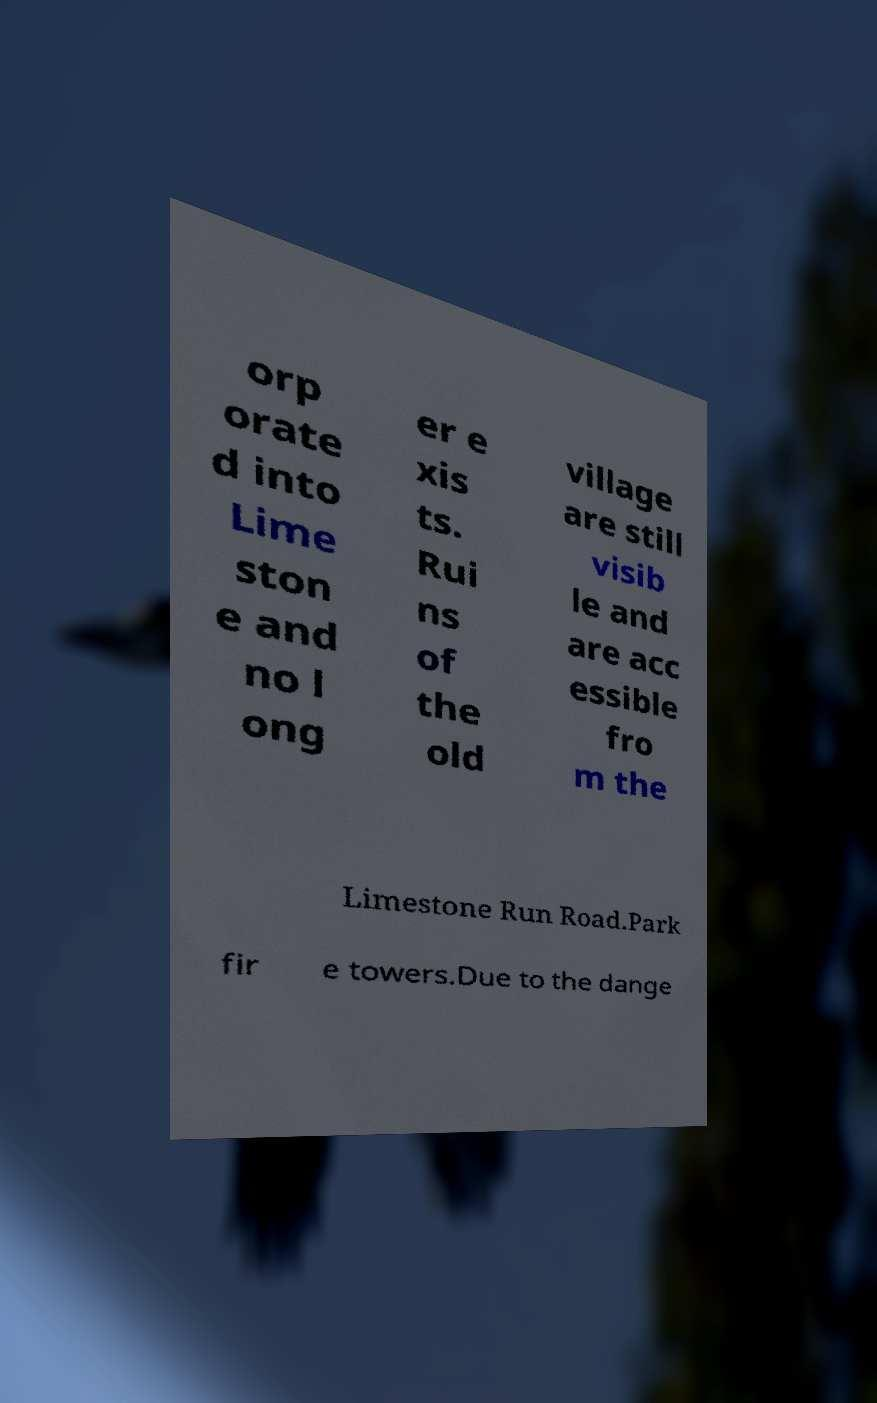For documentation purposes, I need the text within this image transcribed. Could you provide that? orp orate d into Lime ston e and no l ong er e xis ts. Rui ns of the old village are still visib le and are acc essible fro m the Limestone Run Road.Park fir e towers.Due to the dange 